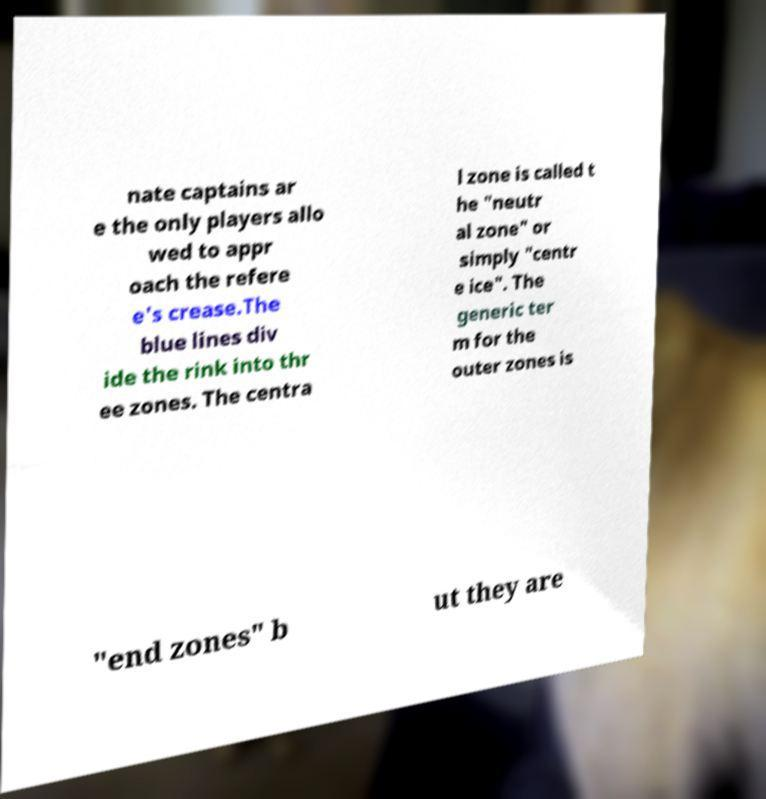I need the written content from this picture converted into text. Can you do that? nate captains ar e the only players allo wed to appr oach the refere e's crease.The blue lines div ide the rink into thr ee zones. The centra l zone is called t he "neutr al zone" or simply "centr e ice". The generic ter m for the outer zones is "end zones" b ut they are 